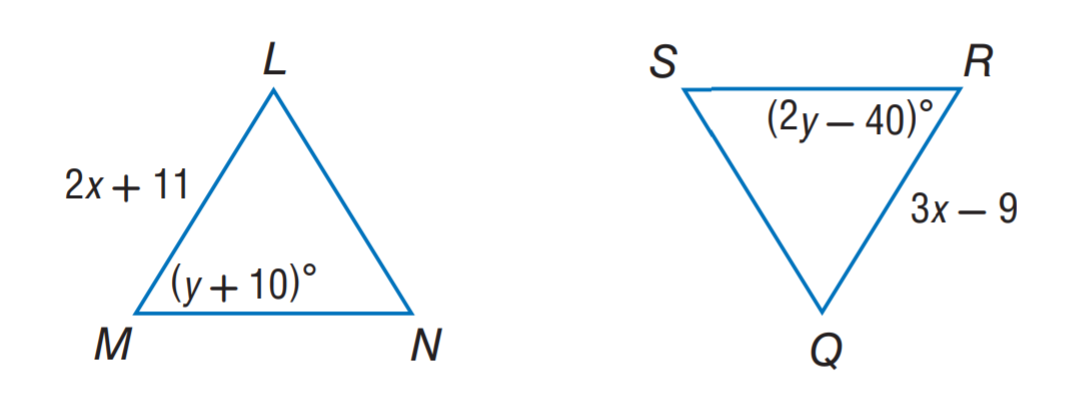Answer the mathemtical geometry problem and directly provide the correct option letter.
Question: \triangle L M N \cong \triangle Q R S. Find y.
Choices: A: 10 B: 20 C: 40 D: 50 D 